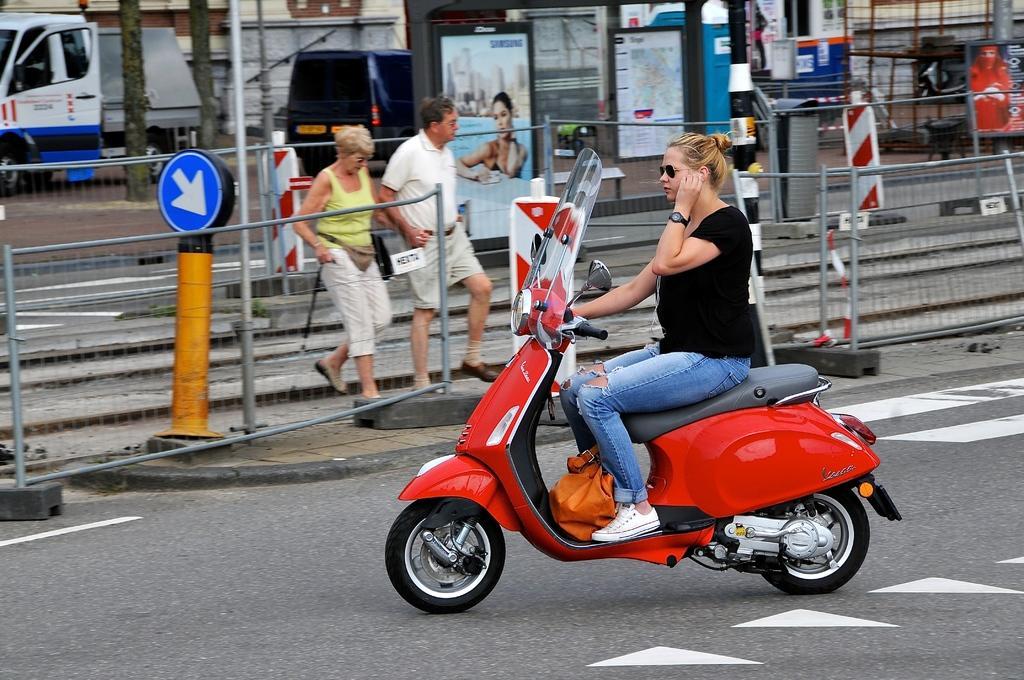Could you give a brief overview of what you see in this image? In this picture I can see a woman is sitting on the bike. The woman is wearing black color glasses. In the background I can see a man and a woman are walking. In the background I can see vehicles on the road, fence, poles, sign boards, trees and other objects. 